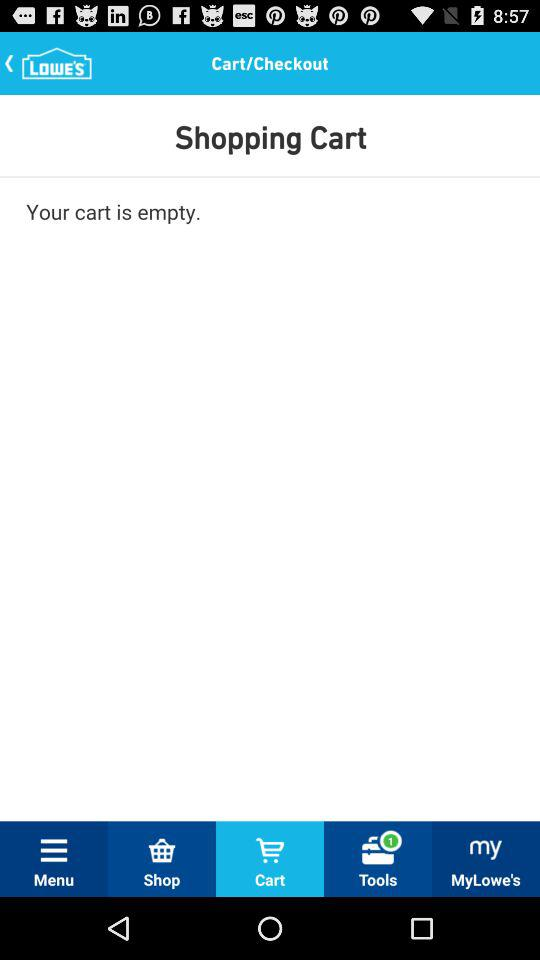How many items are in the cart?
Answer the question using a single word or phrase. 0 